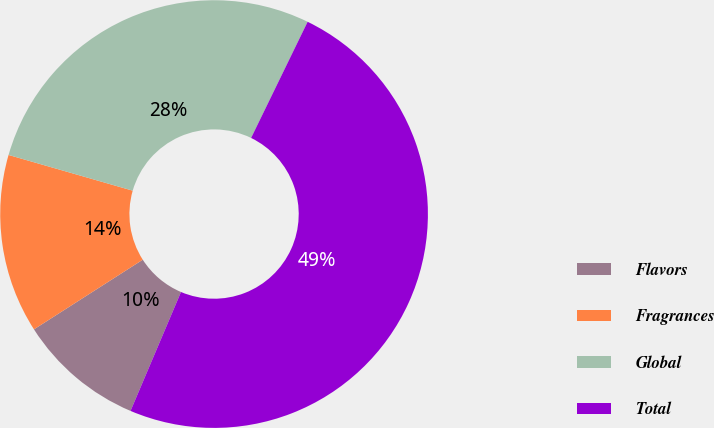Convert chart to OTSL. <chart><loc_0><loc_0><loc_500><loc_500><pie_chart><fcel>Flavors<fcel>Fragrances<fcel>Global<fcel>Total<nl><fcel>9.55%<fcel>13.52%<fcel>27.75%<fcel>49.18%<nl></chart> 